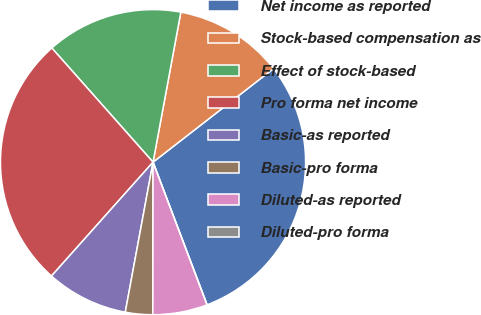Convert chart to OTSL. <chart><loc_0><loc_0><loc_500><loc_500><pie_chart><fcel>Net income as reported<fcel>Stock-based compensation as<fcel>Effect of stock-based<fcel>Pro forma net income<fcel>Basic-as reported<fcel>Basic-pro forma<fcel>Diluted-as reported<fcel>Diluted-pro forma<nl><fcel>29.75%<fcel>11.57%<fcel>14.46%<fcel>26.86%<fcel>8.68%<fcel>2.89%<fcel>5.78%<fcel>0.0%<nl></chart> 